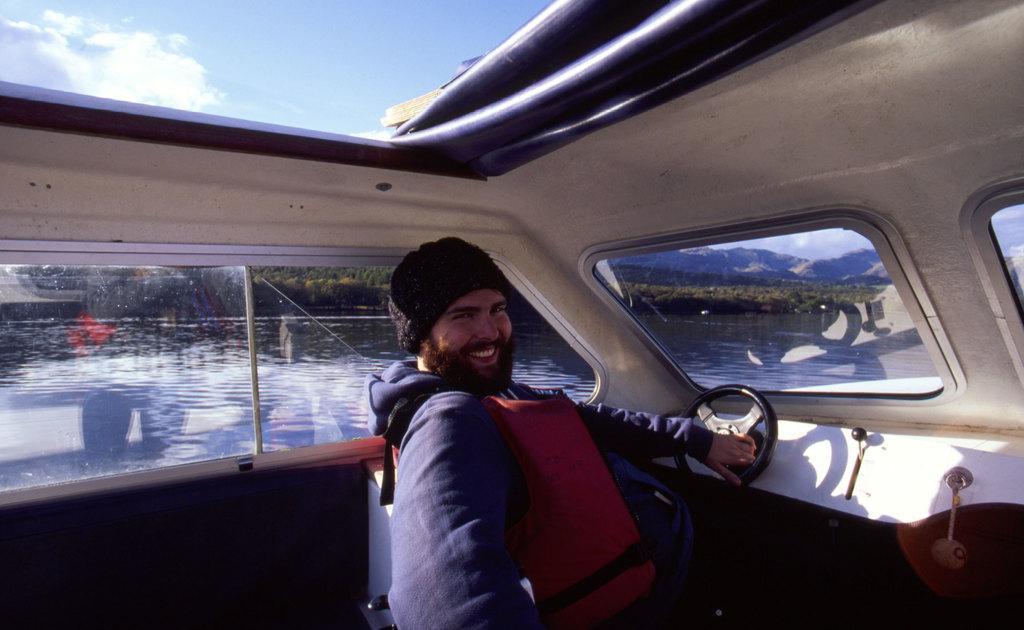How would you summarize this image in a sentence or two? In this image there is one person sitting in to the one boat and the person is wearing a black color cap and holding a steering, and there is a water in middle of this image and there are some trees in the background and there are some mountains at right side of this image and is a cloudy sky at top of this image. 